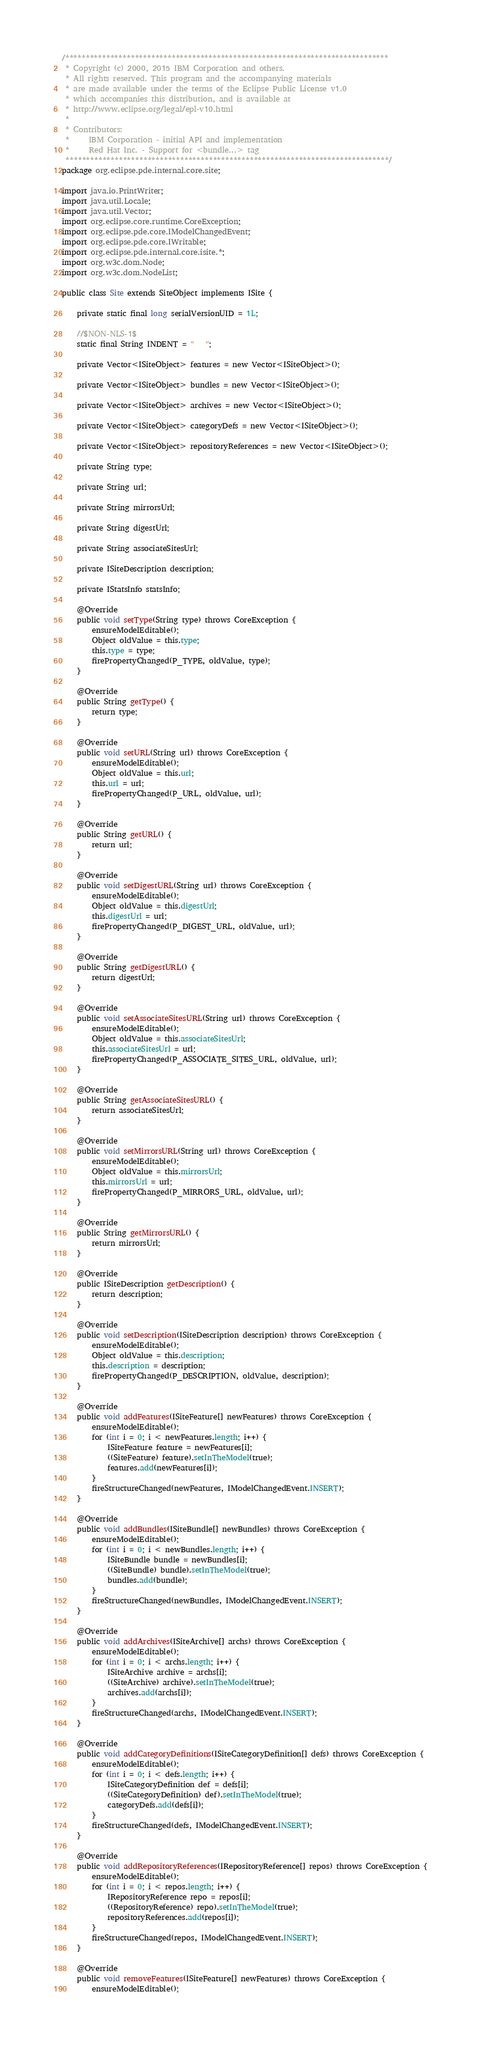Convert code to text. <code><loc_0><loc_0><loc_500><loc_500><_Java_>/*******************************************************************************
 * Copyright (c) 2000, 2015 IBM Corporation and others.
 * All rights reserved. This program and the accompanying materials
 * are made available under the terms of the Eclipse Public License v1.0
 * which accompanies this distribution, and is available at
 * http://www.eclipse.org/legal/epl-v10.html
 *
 * Contributors:
 *     IBM Corporation - initial API and implementation
 *     Red Hat Inc. - Support for <bundle...> tag
 *******************************************************************************/
package org.eclipse.pde.internal.core.site;

import java.io.PrintWriter;
import java.util.Locale;
import java.util.Vector;
import org.eclipse.core.runtime.CoreException;
import org.eclipse.pde.core.IModelChangedEvent;
import org.eclipse.pde.core.IWritable;
import org.eclipse.pde.internal.core.isite.*;
import org.w3c.dom.Node;
import org.w3c.dom.NodeList;

public class Site extends SiteObject implements ISite {

    private static final long serialVersionUID = 1L;

    //$NON-NLS-1$
    static final String INDENT = "   ";

    private Vector<ISiteObject> features = new Vector<ISiteObject>();

    private Vector<ISiteObject> bundles = new Vector<ISiteObject>();

    private Vector<ISiteObject> archives = new Vector<ISiteObject>();

    private Vector<ISiteObject> categoryDefs = new Vector<ISiteObject>();

    private Vector<ISiteObject> repositoryReferences = new Vector<ISiteObject>();

    private String type;

    private String url;

    private String mirrorsUrl;

    private String digestUrl;

    private String associateSitesUrl;

    private ISiteDescription description;

    private IStatsInfo statsInfo;

    @Override
    public void setType(String type) throws CoreException {
        ensureModelEditable();
        Object oldValue = this.type;
        this.type = type;
        firePropertyChanged(P_TYPE, oldValue, type);
    }

    @Override
    public String getType() {
        return type;
    }

    @Override
    public void setURL(String url) throws CoreException {
        ensureModelEditable();
        Object oldValue = this.url;
        this.url = url;
        firePropertyChanged(P_URL, oldValue, url);
    }

    @Override
    public String getURL() {
        return url;
    }

    @Override
    public void setDigestURL(String url) throws CoreException {
        ensureModelEditable();
        Object oldValue = this.digestUrl;
        this.digestUrl = url;
        firePropertyChanged(P_DIGEST_URL, oldValue, url);
    }

    @Override
    public String getDigestURL() {
        return digestUrl;
    }

    @Override
    public void setAssociateSitesURL(String url) throws CoreException {
        ensureModelEditable();
        Object oldValue = this.associateSitesUrl;
        this.associateSitesUrl = url;
        firePropertyChanged(P_ASSOCIATE_SITES_URL, oldValue, url);
    }

    @Override
    public String getAssociateSitesURL() {
        return associateSitesUrl;
    }

    @Override
    public void setMirrorsURL(String url) throws CoreException {
        ensureModelEditable();
        Object oldValue = this.mirrorsUrl;
        this.mirrorsUrl = url;
        firePropertyChanged(P_MIRRORS_URL, oldValue, url);
    }

    @Override
    public String getMirrorsURL() {
        return mirrorsUrl;
    }

    @Override
    public ISiteDescription getDescription() {
        return description;
    }

    @Override
    public void setDescription(ISiteDescription description) throws CoreException {
        ensureModelEditable();
        Object oldValue = this.description;
        this.description = description;
        firePropertyChanged(P_DESCRIPTION, oldValue, description);
    }

    @Override
    public void addFeatures(ISiteFeature[] newFeatures) throws CoreException {
        ensureModelEditable();
        for (int i = 0; i < newFeatures.length; i++) {
            ISiteFeature feature = newFeatures[i];
            ((SiteFeature) feature).setInTheModel(true);
            features.add(newFeatures[i]);
        }
        fireStructureChanged(newFeatures, IModelChangedEvent.INSERT);
    }

    @Override
    public void addBundles(ISiteBundle[] newBundles) throws CoreException {
        ensureModelEditable();
        for (int i = 0; i < newBundles.length; i++) {
            ISiteBundle bundle = newBundles[i];
            ((SiteBundle) bundle).setInTheModel(true);
            bundles.add(bundle);
        }
        fireStructureChanged(newBundles, IModelChangedEvent.INSERT);
    }

    @Override
    public void addArchives(ISiteArchive[] archs) throws CoreException {
        ensureModelEditable();
        for (int i = 0; i < archs.length; i++) {
            ISiteArchive archive = archs[i];
            ((SiteArchive) archive).setInTheModel(true);
            archives.add(archs[i]);
        }
        fireStructureChanged(archs, IModelChangedEvent.INSERT);
    }

    @Override
    public void addCategoryDefinitions(ISiteCategoryDefinition[] defs) throws CoreException {
        ensureModelEditable();
        for (int i = 0; i < defs.length; i++) {
            ISiteCategoryDefinition def = defs[i];
            ((SiteCategoryDefinition) def).setInTheModel(true);
            categoryDefs.add(defs[i]);
        }
        fireStructureChanged(defs, IModelChangedEvent.INSERT);
    }

    @Override
    public void addRepositoryReferences(IRepositoryReference[] repos) throws CoreException {
        ensureModelEditable();
        for (int i = 0; i < repos.length; i++) {
            IRepositoryReference repo = repos[i];
            ((RepositoryReference) repo).setInTheModel(true);
            repositoryReferences.add(repos[i]);
        }
        fireStructureChanged(repos, IModelChangedEvent.INSERT);
    }

    @Override
    public void removeFeatures(ISiteFeature[] newFeatures) throws CoreException {
        ensureModelEditable();</code> 